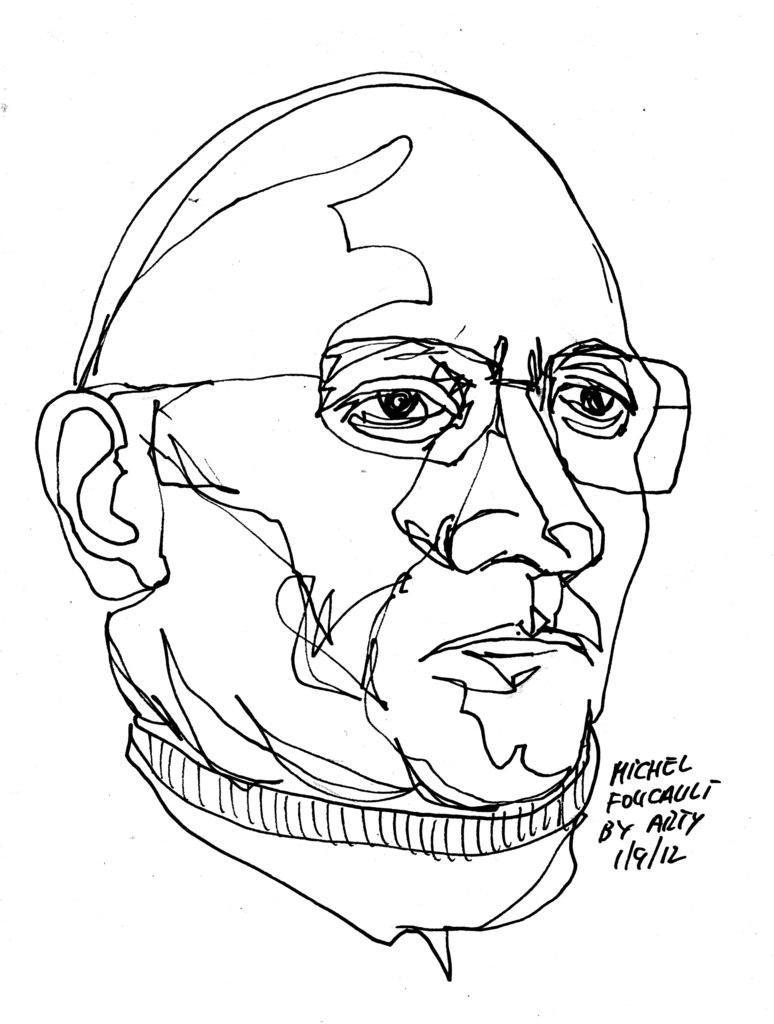Describe this image in one or two sentences. In this image there is a sketch of a person, beside him there is text. 